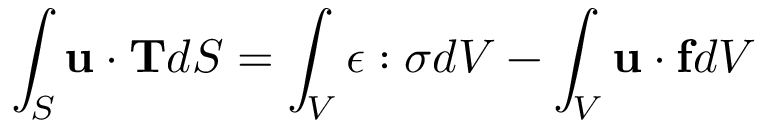<formula> <loc_0><loc_0><loc_500><loc_500>\int _ { S } u \cdot T d S = \int _ { V } { \epsilon } \colon { \sigma } d V - \int _ { V } u \cdot f d V</formula> 